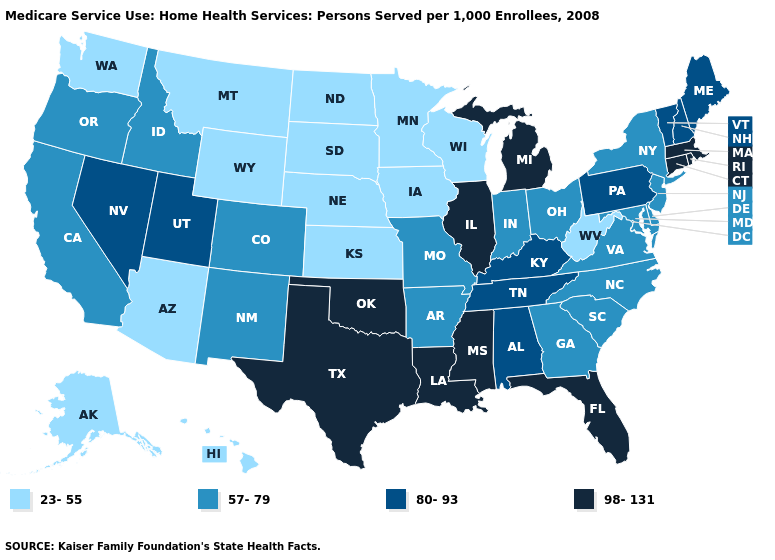What is the value of Washington?
Concise answer only. 23-55. Does Connecticut have the highest value in the USA?
Be succinct. Yes. What is the highest value in the USA?
Be succinct. 98-131. Name the states that have a value in the range 80-93?
Give a very brief answer. Alabama, Kentucky, Maine, Nevada, New Hampshire, Pennsylvania, Tennessee, Utah, Vermont. Name the states that have a value in the range 57-79?
Be succinct. Arkansas, California, Colorado, Delaware, Georgia, Idaho, Indiana, Maryland, Missouri, New Jersey, New Mexico, New York, North Carolina, Ohio, Oregon, South Carolina, Virginia. Does Pennsylvania have the lowest value in the USA?
Answer briefly. No. What is the value of Indiana?
Answer briefly. 57-79. How many symbols are there in the legend?
Write a very short answer. 4. Name the states that have a value in the range 80-93?
Concise answer only. Alabama, Kentucky, Maine, Nevada, New Hampshire, Pennsylvania, Tennessee, Utah, Vermont. How many symbols are there in the legend?
Short answer required. 4. Which states have the lowest value in the USA?
Short answer required. Alaska, Arizona, Hawaii, Iowa, Kansas, Minnesota, Montana, Nebraska, North Dakota, South Dakota, Washington, West Virginia, Wisconsin, Wyoming. Which states have the lowest value in the Northeast?
Write a very short answer. New Jersey, New York. Among the states that border Nebraska , does South Dakota have the highest value?
Give a very brief answer. No. Which states have the lowest value in the USA?
Keep it brief. Alaska, Arizona, Hawaii, Iowa, Kansas, Minnesota, Montana, Nebraska, North Dakota, South Dakota, Washington, West Virginia, Wisconsin, Wyoming. Name the states that have a value in the range 80-93?
Give a very brief answer. Alabama, Kentucky, Maine, Nevada, New Hampshire, Pennsylvania, Tennessee, Utah, Vermont. 